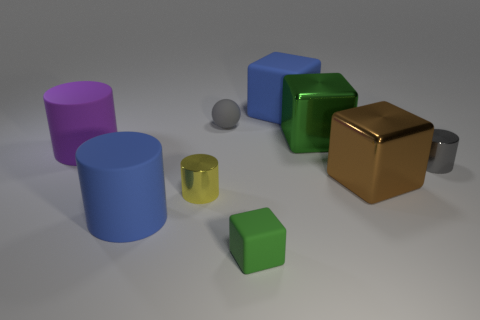Subtract all tiny yellow cylinders. How many cylinders are left? 3 Add 1 rubber things. How many objects exist? 10 Subtract all yellow cubes. Subtract all brown cylinders. How many cubes are left? 4 Subtract all spheres. How many objects are left? 8 Add 8 large green metallic objects. How many large green metallic objects exist? 9 Subtract 0 green cylinders. How many objects are left? 9 Subtract all green shiny cubes. Subtract all purple matte cylinders. How many objects are left? 7 Add 1 blue objects. How many blue objects are left? 3 